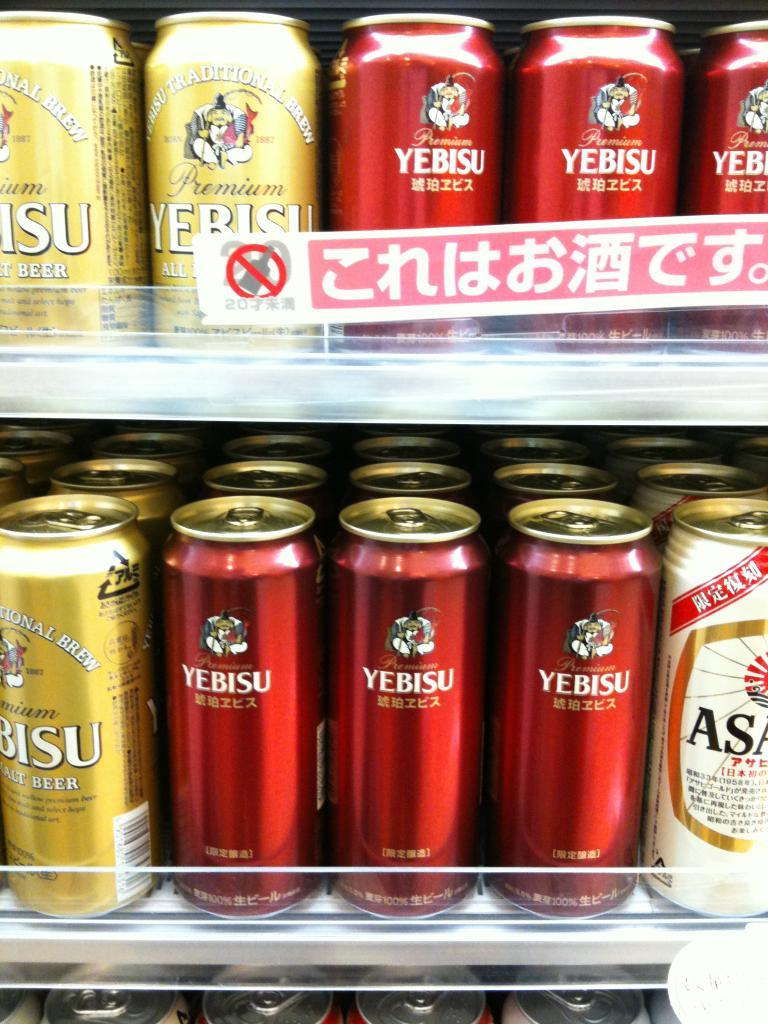<image>
Relay a brief, clear account of the picture shown. Two shelves with various flavours of Yebisu beer in red and gold cans. 